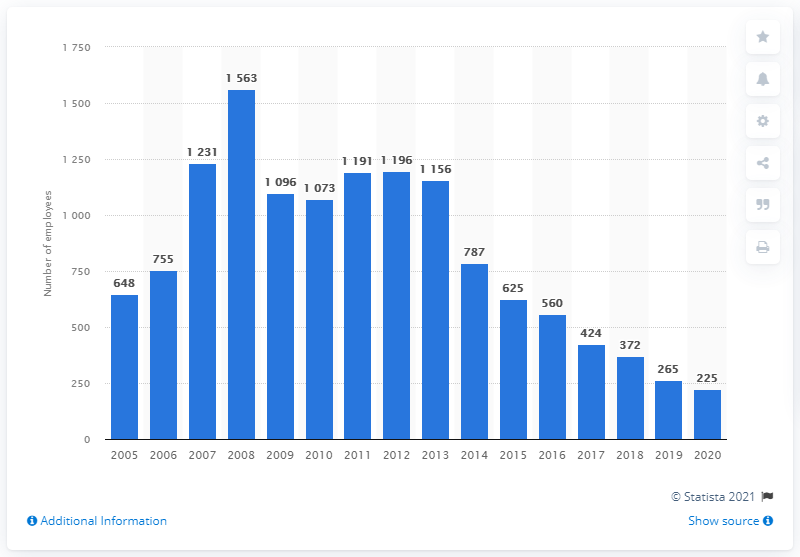Point out several critical features in this image. In 2020, there were 225 individuals employed by the United States uranium mining industry. 